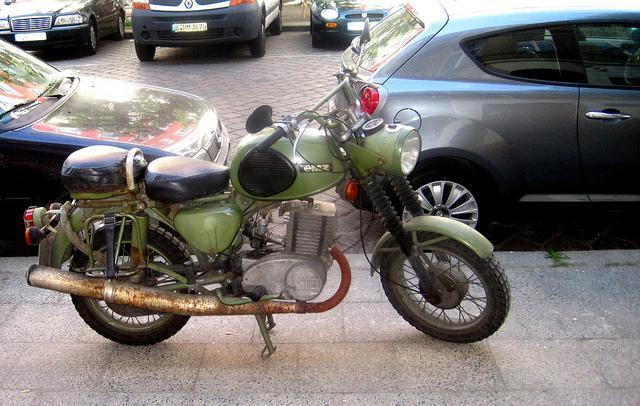How many cars are in this picture?
Give a very brief answer. 5. How many mufflers does the bike have?
Give a very brief answer. 1. How many motorcycles are in the photo?
Give a very brief answer. 1. How many cars are there?
Give a very brief answer. 5. How many people are skating?
Give a very brief answer. 0. 